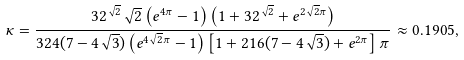Convert formula to latex. <formula><loc_0><loc_0><loc_500><loc_500>\kappa = \frac { 3 2 ^ { \sqrt { 2 } } \sqrt { 2 } \left ( e ^ { 4 \pi } - 1 \right ) \left ( 1 + 3 2 ^ { \sqrt { 2 } } + e ^ { 2 \sqrt { 2 } \pi } \right ) } { 3 2 4 ( 7 - 4 \sqrt { 3 } ) \left ( e ^ { 4 \sqrt { 2 } \pi } - 1 \right ) \left [ 1 + 2 1 6 ( 7 - 4 \sqrt { 3 } ) + e ^ { 2 \pi } \right ] \pi } \approx 0 . 1 9 0 5 ,</formula> 